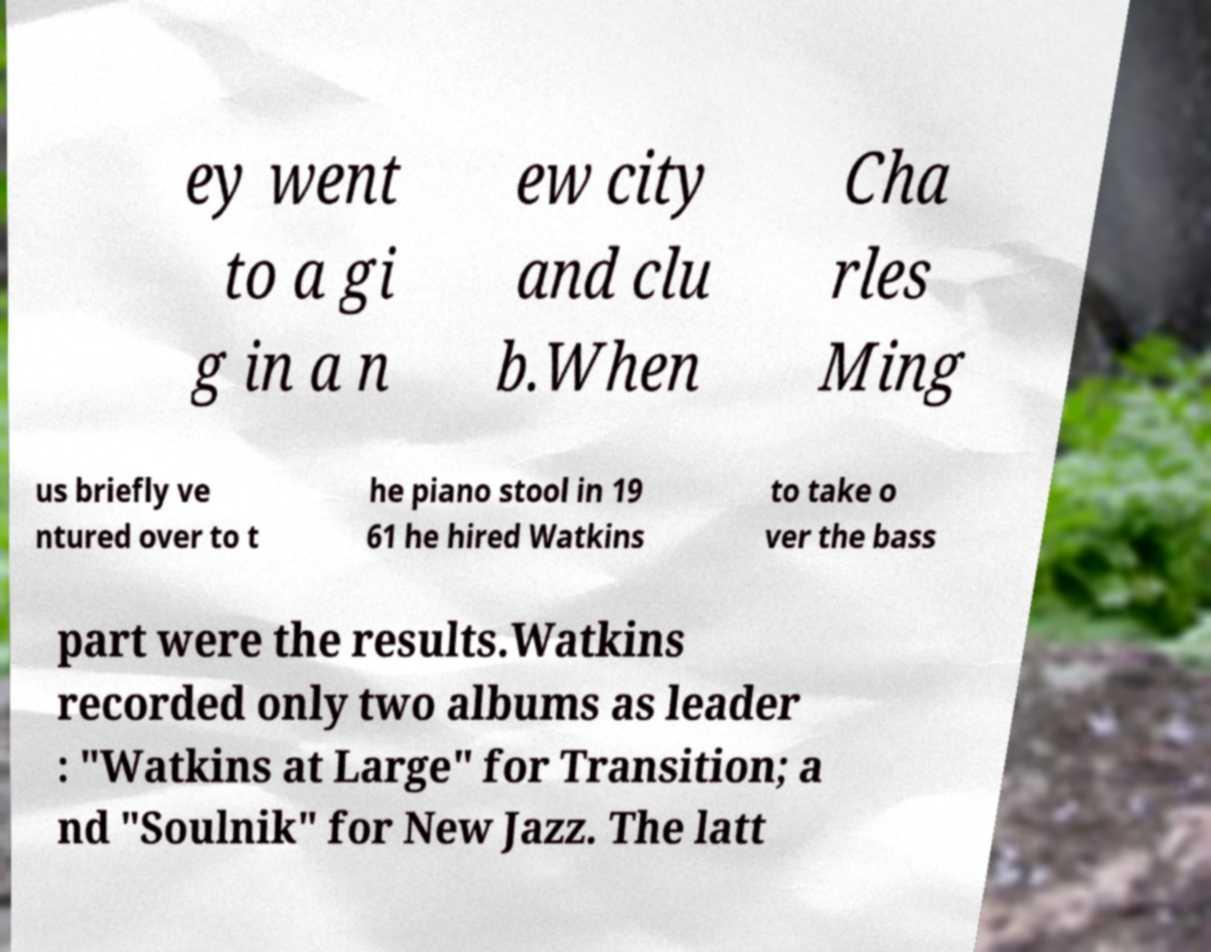Could you extract and type out the text from this image? ey went to a gi g in a n ew city and clu b.When Cha rles Ming us briefly ve ntured over to t he piano stool in 19 61 he hired Watkins to take o ver the bass part were the results.Watkins recorded only two albums as leader : "Watkins at Large" for Transition; a nd "Soulnik" for New Jazz. The latt 